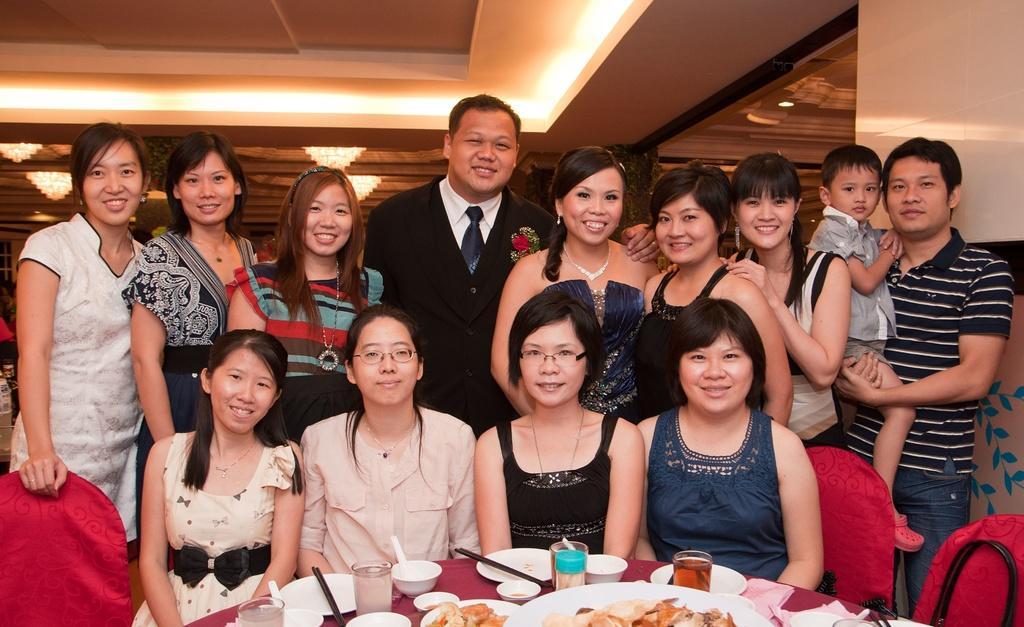Could you give a brief overview of what you see in this image? In this image there are group of people sitting on the chairs and standing and smiling, and there are bowls , spoons, plates, glasses on the table, and in the background there are chandeliers. 